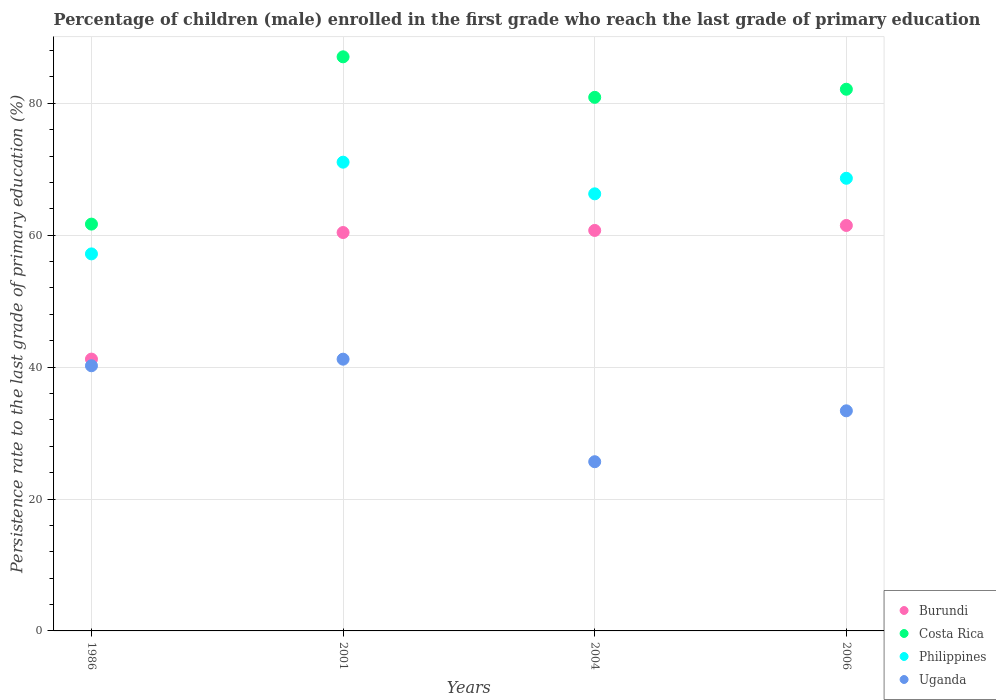What is the persistence rate of children in Burundi in 2006?
Your answer should be very brief. 61.47. Across all years, what is the maximum persistence rate of children in Uganda?
Ensure brevity in your answer.  41.2. Across all years, what is the minimum persistence rate of children in Costa Rica?
Provide a short and direct response. 61.68. In which year was the persistence rate of children in Costa Rica minimum?
Give a very brief answer. 1986. What is the total persistence rate of children in Philippines in the graph?
Ensure brevity in your answer.  263.13. What is the difference between the persistence rate of children in Costa Rica in 2001 and that in 2004?
Keep it short and to the point. 6.14. What is the difference between the persistence rate of children in Philippines in 2006 and the persistence rate of children in Burundi in 2001?
Offer a very short reply. 8.22. What is the average persistence rate of children in Uganda per year?
Provide a short and direct response. 35.11. In the year 2006, what is the difference between the persistence rate of children in Costa Rica and persistence rate of children in Philippines?
Make the answer very short. 13.5. What is the ratio of the persistence rate of children in Uganda in 2001 to that in 2006?
Your answer should be compact. 1.23. Is the persistence rate of children in Costa Rica in 2001 less than that in 2004?
Your answer should be compact. No. Is the difference between the persistence rate of children in Costa Rica in 2001 and 2006 greater than the difference between the persistence rate of children in Philippines in 2001 and 2006?
Your answer should be very brief. Yes. What is the difference between the highest and the second highest persistence rate of children in Uganda?
Provide a short and direct response. 1. What is the difference between the highest and the lowest persistence rate of children in Costa Rica?
Ensure brevity in your answer.  25.36. In how many years, is the persistence rate of children in Costa Rica greater than the average persistence rate of children in Costa Rica taken over all years?
Give a very brief answer. 3. Does the persistence rate of children in Philippines monotonically increase over the years?
Your answer should be very brief. No. How many dotlines are there?
Give a very brief answer. 4. Does the graph contain grids?
Offer a very short reply. Yes. Where does the legend appear in the graph?
Give a very brief answer. Bottom right. How many legend labels are there?
Offer a terse response. 4. How are the legend labels stacked?
Give a very brief answer. Vertical. What is the title of the graph?
Offer a very short reply. Percentage of children (male) enrolled in the first grade who reach the last grade of primary education. What is the label or title of the X-axis?
Offer a very short reply. Years. What is the label or title of the Y-axis?
Offer a terse response. Persistence rate to the last grade of primary education (%). What is the Persistence rate to the last grade of primary education (%) in Burundi in 1986?
Your answer should be compact. 41.21. What is the Persistence rate to the last grade of primary education (%) of Costa Rica in 1986?
Keep it short and to the point. 61.68. What is the Persistence rate to the last grade of primary education (%) of Philippines in 1986?
Your answer should be compact. 57.16. What is the Persistence rate to the last grade of primary education (%) of Uganda in 1986?
Make the answer very short. 40.2. What is the Persistence rate to the last grade of primary education (%) in Burundi in 2001?
Give a very brief answer. 60.4. What is the Persistence rate to the last grade of primary education (%) in Costa Rica in 2001?
Offer a terse response. 87.04. What is the Persistence rate to the last grade of primary education (%) of Philippines in 2001?
Ensure brevity in your answer.  71.07. What is the Persistence rate to the last grade of primary education (%) in Uganda in 2001?
Your answer should be very brief. 41.2. What is the Persistence rate to the last grade of primary education (%) in Burundi in 2004?
Keep it short and to the point. 60.72. What is the Persistence rate to the last grade of primary education (%) in Costa Rica in 2004?
Keep it short and to the point. 80.9. What is the Persistence rate to the last grade of primary education (%) of Philippines in 2004?
Provide a short and direct response. 66.27. What is the Persistence rate to the last grade of primary education (%) in Uganda in 2004?
Give a very brief answer. 25.65. What is the Persistence rate to the last grade of primary education (%) of Burundi in 2006?
Your answer should be compact. 61.47. What is the Persistence rate to the last grade of primary education (%) of Costa Rica in 2006?
Offer a very short reply. 82.13. What is the Persistence rate to the last grade of primary education (%) in Philippines in 2006?
Your response must be concise. 68.63. What is the Persistence rate to the last grade of primary education (%) in Uganda in 2006?
Provide a short and direct response. 33.37. Across all years, what is the maximum Persistence rate to the last grade of primary education (%) in Burundi?
Make the answer very short. 61.47. Across all years, what is the maximum Persistence rate to the last grade of primary education (%) in Costa Rica?
Your answer should be compact. 87.04. Across all years, what is the maximum Persistence rate to the last grade of primary education (%) of Philippines?
Make the answer very short. 71.07. Across all years, what is the maximum Persistence rate to the last grade of primary education (%) of Uganda?
Offer a very short reply. 41.2. Across all years, what is the minimum Persistence rate to the last grade of primary education (%) in Burundi?
Provide a succinct answer. 41.21. Across all years, what is the minimum Persistence rate to the last grade of primary education (%) in Costa Rica?
Offer a very short reply. 61.68. Across all years, what is the minimum Persistence rate to the last grade of primary education (%) of Philippines?
Offer a terse response. 57.16. Across all years, what is the minimum Persistence rate to the last grade of primary education (%) of Uganda?
Offer a terse response. 25.65. What is the total Persistence rate to the last grade of primary education (%) of Burundi in the graph?
Your answer should be very brief. 223.81. What is the total Persistence rate to the last grade of primary education (%) in Costa Rica in the graph?
Offer a very short reply. 311.74. What is the total Persistence rate to the last grade of primary education (%) in Philippines in the graph?
Provide a short and direct response. 263.13. What is the total Persistence rate to the last grade of primary education (%) of Uganda in the graph?
Ensure brevity in your answer.  140.43. What is the difference between the Persistence rate to the last grade of primary education (%) of Burundi in 1986 and that in 2001?
Ensure brevity in your answer.  -19.19. What is the difference between the Persistence rate to the last grade of primary education (%) in Costa Rica in 1986 and that in 2001?
Your answer should be compact. -25.36. What is the difference between the Persistence rate to the last grade of primary education (%) in Philippines in 1986 and that in 2001?
Offer a very short reply. -13.91. What is the difference between the Persistence rate to the last grade of primary education (%) of Uganda in 1986 and that in 2001?
Provide a short and direct response. -1. What is the difference between the Persistence rate to the last grade of primary education (%) in Burundi in 1986 and that in 2004?
Offer a terse response. -19.51. What is the difference between the Persistence rate to the last grade of primary education (%) of Costa Rica in 1986 and that in 2004?
Give a very brief answer. -19.22. What is the difference between the Persistence rate to the last grade of primary education (%) of Philippines in 1986 and that in 2004?
Make the answer very short. -9.11. What is the difference between the Persistence rate to the last grade of primary education (%) of Uganda in 1986 and that in 2004?
Your response must be concise. 14.55. What is the difference between the Persistence rate to the last grade of primary education (%) in Burundi in 1986 and that in 2006?
Give a very brief answer. -20.26. What is the difference between the Persistence rate to the last grade of primary education (%) of Costa Rica in 1986 and that in 2006?
Keep it short and to the point. -20.45. What is the difference between the Persistence rate to the last grade of primary education (%) in Philippines in 1986 and that in 2006?
Your response must be concise. -11.46. What is the difference between the Persistence rate to the last grade of primary education (%) in Uganda in 1986 and that in 2006?
Keep it short and to the point. 6.83. What is the difference between the Persistence rate to the last grade of primary education (%) in Burundi in 2001 and that in 2004?
Offer a terse response. -0.32. What is the difference between the Persistence rate to the last grade of primary education (%) of Costa Rica in 2001 and that in 2004?
Offer a very short reply. 6.14. What is the difference between the Persistence rate to the last grade of primary education (%) in Philippines in 2001 and that in 2004?
Ensure brevity in your answer.  4.8. What is the difference between the Persistence rate to the last grade of primary education (%) of Uganda in 2001 and that in 2004?
Your answer should be compact. 15.55. What is the difference between the Persistence rate to the last grade of primary education (%) in Burundi in 2001 and that in 2006?
Provide a succinct answer. -1.07. What is the difference between the Persistence rate to the last grade of primary education (%) in Costa Rica in 2001 and that in 2006?
Keep it short and to the point. 4.92. What is the difference between the Persistence rate to the last grade of primary education (%) in Philippines in 2001 and that in 2006?
Your answer should be very brief. 2.44. What is the difference between the Persistence rate to the last grade of primary education (%) in Uganda in 2001 and that in 2006?
Make the answer very short. 7.83. What is the difference between the Persistence rate to the last grade of primary education (%) of Burundi in 2004 and that in 2006?
Make the answer very short. -0.75. What is the difference between the Persistence rate to the last grade of primary education (%) in Costa Rica in 2004 and that in 2006?
Provide a succinct answer. -1.23. What is the difference between the Persistence rate to the last grade of primary education (%) of Philippines in 2004 and that in 2006?
Your answer should be very brief. -2.36. What is the difference between the Persistence rate to the last grade of primary education (%) of Uganda in 2004 and that in 2006?
Offer a very short reply. -7.72. What is the difference between the Persistence rate to the last grade of primary education (%) in Burundi in 1986 and the Persistence rate to the last grade of primary education (%) in Costa Rica in 2001?
Your response must be concise. -45.83. What is the difference between the Persistence rate to the last grade of primary education (%) of Burundi in 1986 and the Persistence rate to the last grade of primary education (%) of Philippines in 2001?
Provide a short and direct response. -29.86. What is the difference between the Persistence rate to the last grade of primary education (%) of Burundi in 1986 and the Persistence rate to the last grade of primary education (%) of Uganda in 2001?
Give a very brief answer. 0.01. What is the difference between the Persistence rate to the last grade of primary education (%) in Costa Rica in 1986 and the Persistence rate to the last grade of primary education (%) in Philippines in 2001?
Ensure brevity in your answer.  -9.39. What is the difference between the Persistence rate to the last grade of primary education (%) of Costa Rica in 1986 and the Persistence rate to the last grade of primary education (%) of Uganda in 2001?
Your response must be concise. 20.48. What is the difference between the Persistence rate to the last grade of primary education (%) in Philippines in 1986 and the Persistence rate to the last grade of primary education (%) in Uganda in 2001?
Offer a terse response. 15.96. What is the difference between the Persistence rate to the last grade of primary education (%) of Burundi in 1986 and the Persistence rate to the last grade of primary education (%) of Costa Rica in 2004?
Provide a succinct answer. -39.69. What is the difference between the Persistence rate to the last grade of primary education (%) in Burundi in 1986 and the Persistence rate to the last grade of primary education (%) in Philippines in 2004?
Provide a short and direct response. -25.06. What is the difference between the Persistence rate to the last grade of primary education (%) in Burundi in 1986 and the Persistence rate to the last grade of primary education (%) in Uganda in 2004?
Offer a terse response. 15.56. What is the difference between the Persistence rate to the last grade of primary education (%) of Costa Rica in 1986 and the Persistence rate to the last grade of primary education (%) of Philippines in 2004?
Ensure brevity in your answer.  -4.59. What is the difference between the Persistence rate to the last grade of primary education (%) in Costa Rica in 1986 and the Persistence rate to the last grade of primary education (%) in Uganda in 2004?
Keep it short and to the point. 36.02. What is the difference between the Persistence rate to the last grade of primary education (%) of Philippines in 1986 and the Persistence rate to the last grade of primary education (%) of Uganda in 2004?
Ensure brevity in your answer.  31.51. What is the difference between the Persistence rate to the last grade of primary education (%) of Burundi in 1986 and the Persistence rate to the last grade of primary education (%) of Costa Rica in 2006?
Offer a very short reply. -40.91. What is the difference between the Persistence rate to the last grade of primary education (%) of Burundi in 1986 and the Persistence rate to the last grade of primary education (%) of Philippines in 2006?
Your response must be concise. -27.42. What is the difference between the Persistence rate to the last grade of primary education (%) of Burundi in 1986 and the Persistence rate to the last grade of primary education (%) of Uganda in 2006?
Ensure brevity in your answer.  7.84. What is the difference between the Persistence rate to the last grade of primary education (%) of Costa Rica in 1986 and the Persistence rate to the last grade of primary education (%) of Philippines in 2006?
Your response must be concise. -6.95. What is the difference between the Persistence rate to the last grade of primary education (%) in Costa Rica in 1986 and the Persistence rate to the last grade of primary education (%) in Uganda in 2006?
Make the answer very short. 28.31. What is the difference between the Persistence rate to the last grade of primary education (%) of Philippines in 1986 and the Persistence rate to the last grade of primary education (%) of Uganda in 2006?
Give a very brief answer. 23.79. What is the difference between the Persistence rate to the last grade of primary education (%) in Burundi in 2001 and the Persistence rate to the last grade of primary education (%) in Costa Rica in 2004?
Your answer should be compact. -20.5. What is the difference between the Persistence rate to the last grade of primary education (%) of Burundi in 2001 and the Persistence rate to the last grade of primary education (%) of Philippines in 2004?
Keep it short and to the point. -5.87. What is the difference between the Persistence rate to the last grade of primary education (%) of Burundi in 2001 and the Persistence rate to the last grade of primary education (%) of Uganda in 2004?
Your response must be concise. 34.75. What is the difference between the Persistence rate to the last grade of primary education (%) in Costa Rica in 2001 and the Persistence rate to the last grade of primary education (%) in Philippines in 2004?
Offer a very short reply. 20.77. What is the difference between the Persistence rate to the last grade of primary education (%) of Costa Rica in 2001 and the Persistence rate to the last grade of primary education (%) of Uganda in 2004?
Provide a succinct answer. 61.39. What is the difference between the Persistence rate to the last grade of primary education (%) in Philippines in 2001 and the Persistence rate to the last grade of primary education (%) in Uganda in 2004?
Provide a short and direct response. 45.41. What is the difference between the Persistence rate to the last grade of primary education (%) of Burundi in 2001 and the Persistence rate to the last grade of primary education (%) of Costa Rica in 2006?
Your response must be concise. -21.72. What is the difference between the Persistence rate to the last grade of primary education (%) in Burundi in 2001 and the Persistence rate to the last grade of primary education (%) in Philippines in 2006?
Provide a succinct answer. -8.22. What is the difference between the Persistence rate to the last grade of primary education (%) of Burundi in 2001 and the Persistence rate to the last grade of primary education (%) of Uganda in 2006?
Keep it short and to the point. 27.03. What is the difference between the Persistence rate to the last grade of primary education (%) of Costa Rica in 2001 and the Persistence rate to the last grade of primary education (%) of Philippines in 2006?
Offer a terse response. 18.41. What is the difference between the Persistence rate to the last grade of primary education (%) in Costa Rica in 2001 and the Persistence rate to the last grade of primary education (%) in Uganda in 2006?
Your answer should be compact. 53.67. What is the difference between the Persistence rate to the last grade of primary education (%) of Philippines in 2001 and the Persistence rate to the last grade of primary education (%) of Uganda in 2006?
Your answer should be compact. 37.7. What is the difference between the Persistence rate to the last grade of primary education (%) of Burundi in 2004 and the Persistence rate to the last grade of primary education (%) of Costa Rica in 2006?
Your response must be concise. -21.41. What is the difference between the Persistence rate to the last grade of primary education (%) of Burundi in 2004 and the Persistence rate to the last grade of primary education (%) of Philippines in 2006?
Keep it short and to the point. -7.91. What is the difference between the Persistence rate to the last grade of primary education (%) in Burundi in 2004 and the Persistence rate to the last grade of primary education (%) in Uganda in 2006?
Ensure brevity in your answer.  27.35. What is the difference between the Persistence rate to the last grade of primary education (%) in Costa Rica in 2004 and the Persistence rate to the last grade of primary education (%) in Philippines in 2006?
Your response must be concise. 12.27. What is the difference between the Persistence rate to the last grade of primary education (%) of Costa Rica in 2004 and the Persistence rate to the last grade of primary education (%) of Uganda in 2006?
Your response must be concise. 47.53. What is the difference between the Persistence rate to the last grade of primary education (%) of Philippines in 2004 and the Persistence rate to the last grade of primary education (%) of Uganda in 2006?
Ensure brevity in your answer.  32.9. What is the average Persistence rate to the last grade of primary education (%) in Burundi per year?
Offer a very short reply. 55.95. What is the average Persistence rate to the last grade of primary education (%) of Costa Rica per year?
Offer a very short reply. 77.94. What is the average Persistence rate to the last grade of primary education (%) of Philippines per year?
Your response must be concise. 65.78. What is the average Persistence rate to the last grade of primary education (%) in Uganda per year?
Your answer should be compact. 35.11. In the year 1986, what is the difference between the Persistence rate to the last grade of primary education (%) in Burundi and Persistence rate to the last grade of primary education (%) in Costa Rica?
Your response must be concise. -20.47. In the year 1986, what is the difference between the Persistence rate to the last grade of primary education (%) of Burundi and Persistence rate to the last grade of primary education (%) of Philippines?
Ensure brevity in your answer.  -15.95. In the year 1986, what is the difference between the Persistence rate to the last grade of primary education (%) of Burundi and Persistence rate to the last grade of primary education (%) of Uganda?
Make the answer very short. 1.01. In the year 1986, what is the difference between the Persistence rate to the last grade of primary education (%) in Costa Rica and Persistence rate to the last grade of primary education (%) in Philippines?
Ensure brevity in your answer.  4.52. In the year 1986, what is the difference between the Persistence rate to the last grade of primary education (%) in Costa Rica and Persistence rate to the last grade of primary education (%) in Uganda?
Your answer should be very brief. 21.48. In the year 1986, what is the difference between the Persistence rate to the last grade of primary education (%) of Philippines and Persistence rate to the last grade of primary education (%) of Uganda?
Provide a succinct answer. 16.96. In the year 2001, what is the difference between the Persistence rate to the last grade of primary education (%) of Burundi and Persistence rate to the last grade of primary education (%) of Costa Rica?
Your answer should be very brief. -26.64. In the year 2001, what is the difference between the Persistence rate to the last grade of primary education (%) in Burundi and Persistence rate to the last grade of primary education (%) in Philippines?
Provide a short and direct response. -10.67. In the year 2001, what is the difference between the Persistence rate to the last grade of primary education (%) of Burundi and Persistence rate to the last grade of primary education (%) of Uganda?
Offer a terse response. 19.2. In the year 2001, what is the difference between the Persistence rate to the last grade of primary education (%) in Costa Rica and Persistence rate to the last grade of primary education (%) in Philippines?
Offer a terse response. 15.97. In the year 2001, what is the difference between the Persistence rate to the last grade of primary education (%) in Costa Rica and Persistence rate to the last grade of primary education (%) in Uganda?
Make the answer very short. 45.84. In the year 2001, what is the difference between the Persistence rate to the last grade of primary education (%) of Philippines and Persistence rate to the last grade of primary education (%) of Uganda?
Offer a very short reply. 29.87. In the year 2004, what is the difference between the Persistence rate to the last grade of primary education (%) in Burundi and Persistence rate to the last grade of primary education (%) in Costa Rica?
Keep it short and to the point. -20.18. In the year 2004, what is the difference between the Persistence rate to the last grade of primary education (%) of Burundi and Persistence rate to the last grade of primary education (%) of Philippines?
Your answer should be very brief. -5.55. In the year 2004, what is the difference between the Persistence rate to the last grade of primary education (%) in Burundi and Persistence rate to the last grade of primary education (%) in Uganda?
Your answer should be very brief. 35.07. In the year 2004, what is the difference between the Persistence rate to the last grade of primary education (%) in Costa Rica and Persistence rate to the last grade of primary education (%) in Philippines?
Give a very brief answer. 14.63. In the year 2004, what is the difference between the Persistence rate to the last grade of primary education (%) of Costa Rica and Persistence rate to the last grade of primary education (%) of Uganda?
Provide a short and direct response. 55.24. In the year 2004, what is the difference between the Persistence rate to the last grade of primary education (%) in Philippines and Persistence rate to the last grade of primary education (%) in Uganda?
Give a very brief answer. 40.62. In the year 2006, what is the difference between the Persistence rate to the last grade of primary education (%) in Burundi and Persistence rate to the last grade of primary education (%) in Costa Rica?
Offer a very short reply. -20.65. In the year 2006, what is the difference between the Persistence rate to the last grade of primary education (%) in Burundi and Persistence rate to the last grade of primary education (%) in Philippines?
Ensure brevity in your answer.  -7.16. In the year 2006, what is the difference between the Persistence rate to the last grade of primary education (%) in Burundi and Persistence rate to the last grade of primary education (%) in Uganda?
Ensure brevity in your answer.  28.1. In the year 2006, what is the difference between the Persistence rate to the last grade of primary education (%) in Costa Rica and Persistence rate to the last grade of primary education (%) in Philippines?
Your answer should be very brief. 13.5. In the year 2006, what is the difference between the Persistence rate to the last grade of primary education (%) of Costa Rica and Persistence rate to the last grade of primary education (%) of Uganda?
Ensure brevity in your answer.  48.76. In the year 2006, what is the difference between the Persistence rate to the last grade of primary education (%) in Philippines and Persistence rate to the last grade of primary education (%) in Uganda?
Provide a succinct answer. 35.26. What is the ratio of the Persistence rate to the last grade of primary education (%) of Burundi in 1986 to that in 2001?
Make the answer very short. 0.68. What is the ratio of the Persistence rate to the last grade of primary education (%) of Costa Rica in 1986 to that in 2001?
Make the answer very short. 0.71. What is the ratio of the Persistence rate to the last grade of primary education (%) in Philippines in 1986 to that in 2001?
Your response must be concise. 0.8. What is the ratio of the Persistence rate to the last grade of primary education (%) of Uganda in 1986 to that in 2001?
Give a very brief answer. 0.98. What is the ratio of the Persistence rate to the last grade of primary education (%) of Burundi in 1986 to that in 2004?
Provide a succinct answer. 0.68. What is the ratio of the Persistence rate to the last grade of primary education (%) in Costa Rica in 1986 to that in 2004?
Offer a very short reply. 0.76. What is the ratio of the Persistence rate to the last grade of primary education (%) of Philippines in 1986 to that in 2004?
Provide a short and direct response. 0.86. What is the ratio of the Persistence rate to the last grade of primary education (%) of Uganda in 1986 to that in 2004?
Offer a very short reply. 1.57. What is the ratio of the Persistence rate to the last grade of primary education (%) of Burundi in 1986 to that in 2006?
Offer a terse response. 0.67. What is the ratio of the Persistence rate to the last grade of primary education (%) of Costa Rica in 1986 to that in 2006?
Offer a very short reply. 0.75. What is the ratio of the Persistence rate to the last grade of primary education (%) in Philippines in 1986 to that in 2006?
Your answer should be compact. 0.83. What is the ratio of the Persistence rate to the last grade of primary education (%) of Uganda in 1986 to that in 2006?
Keep it short and to the point. 1.2. What is the ratio of the Persistence rate to the last grade of primary education (%) of Burundi in 2001 to that in 2004?
Your answer should be very brief. 0.99. What is the ratio of the Persistence rate to the last grade of primary education (%) of Costa Rica in 2001 to that in 2004?
Keep it short and to the point. 1.08. What is the ratio of the Persistence rate to the last grade of primary education (%) of Philippines in 2001 to that in 2004?
Keep it short and to the point. 1.07. What is the ratio of the Persistence rate to the last grade of primary education (%) of Uganda in 2001 to that in 2004?
Your answer should be compact. 1.61. What is the ratio of the Persistence rate to the last grade of primary education (%) in Burundi in 2001 to that in 2006?
Provide a succinct answer. 0.98. What is the ratio of the Persistence rate to the last grade of primary education (%) of Costa Rica in 2001 to that in 2006?
Provide a succinct answer. 1.06. What is the ratio of the Persistence rate to the last grade of primary education (%) of Philippines in 2001 to that in 2006?
Keep it short and to the point. 1.04. What is the ratio of the Persistence rate to the last grade of primary education (%) in Uganda in 2001 to that in 2006?
Offer a very short reply. 1.23. What is the ratio of the Persistence rate to the last grade of primary education (%) of Burundi in 2004 to that in 2006?
Make the answer very short. 0.99. What is the ratio of the Persistence rate to the last grade of primary education (%) of Philippines in 2004 to that in 2006?
Offer a terse response. 0.97. What is the ratio of the Persistence rate to the last grade of primary education (%) in Uganda in 2004 to that in 2006?
Provide a succinct answer. 0.77. What is the difference between the highest and the second highest Persistence rate to the last grade of primary education (%) in Burundi?
Give a very brief answer. 0.75. What is the difference between the highest and the second highest Persistence rate to the last grade of primary education (%) in Costa Rica?
Offer a terse response. 4.92. What is the difference between the highest and the second highest Persistence rate to the last grade of primary education (%) of Philippines?
Provide a succinct answer. 2.44. What is the difference between the highest and the lowest Persistence rate to the last grade of primary education (%) in Burundi?
Your answer should be very brief. 20.26. What is the difference between the highest and the lowest Persistence rate to the last grade of primary education (%) in Costa Rica?
Ensure brevity in your answer.  25.36. What is the difference between the highest and the lowest Persistence rate to the last grade of primary education (%) in Philippines?
Make the answer very short. 13.91. What is the difference between the highest and the lowest Persistence rate to the last grade of primary education (%) in Uganda?
Keep it short and to the point. 15.55. 